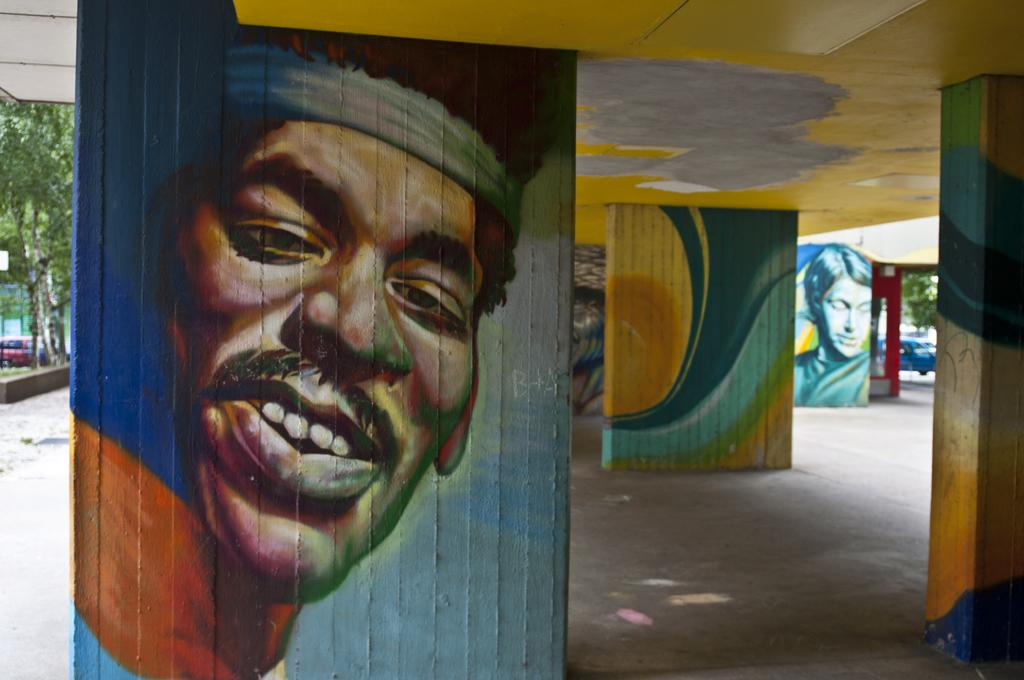What type of structure is partially visible in the image? There is a part of a building in the image. What can be observed about the building's wall? The wall of the building is painted. What type of vegetation is present in the image? There is grass and trees in the image. What mode of transportation can be seen on the road in the image? There are cars on the road in the image. How many cakes are being served by the mice in the image? There are no mice or cakes present in the image. 